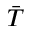<formula> <loc_0><loc_0><loc_500><loc_500>\bar { T }</formula> 